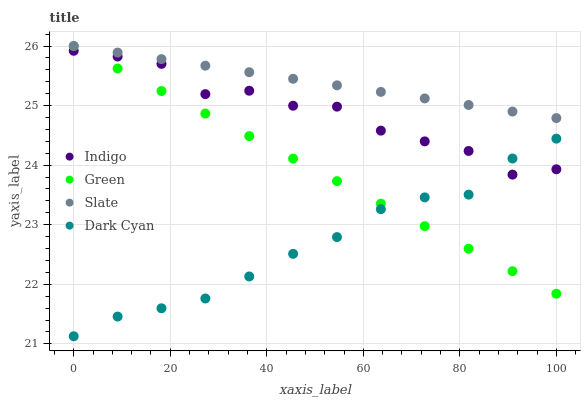Does Dark Cyan have the minimum area under the curve?
Answer yes or no. Yes. Does Slate have the maximum area under the curve?
Answer yes or no. Yes. Does Green have the minimum area under the curve?
Answer yes or no. No. Does Green have the maximum area under the curve?
Answer yes or no. No. Is Green the smoothest?
Answer yes or no. Yes. Is Indigo the roughest?
Answer yes or no. Yes. Is Slate the smoothest?
Answer yes or no. No. Is Slate the roughest?
Answer yes or no. No. Does Dark Cyan have the lowest value?
Answer yes or no. Yes. Does Green have the lowest value?
Answer yes or no. No. Does Slate have the highest value?
Answer yes or no. Yes. Does Indigo have the highest value?
Answer yes or no. No. Is Indigo less than Slate?
Answer yes or no. Yes. Is Slate greater than Indigo?
Answer yes or no. Yes. Does Dark Cyan intersect Green?
Answer yes or no. Yes. Is Dark Cyan less than Green?
Answer yes or no. No. Is Dark Cyan greater than Green?
Answer yes or no. No. Does Indigo intersect Slate?
Answer yes or no. No. 